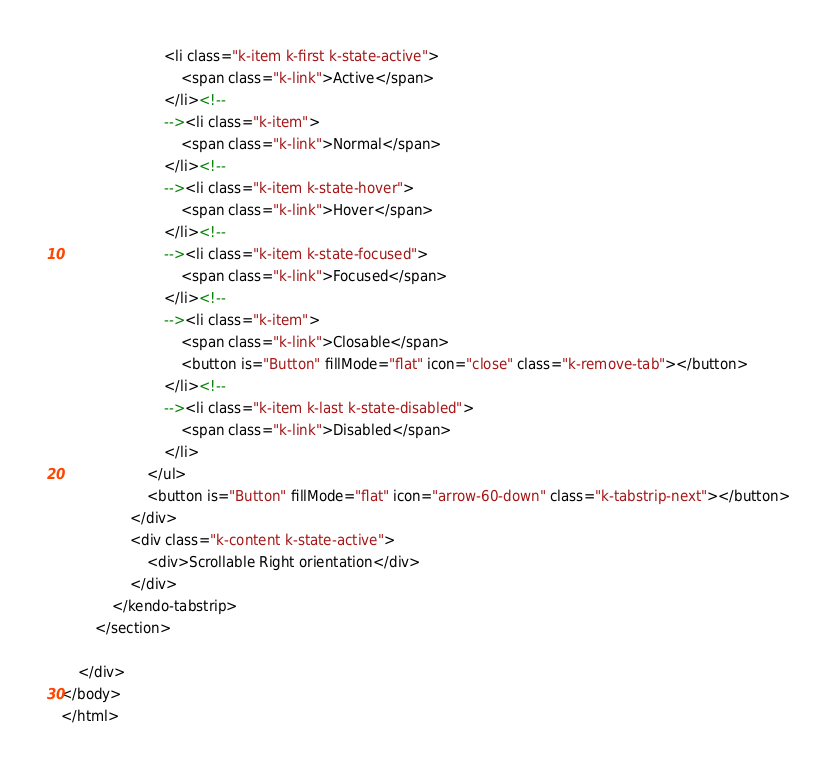<code> <loc_0><loc_0><loc_500><loc_500><_HTML_>                        <li class="k-item k-first k-state-active">
                            <span class="k-link">Active</span>
                        </li><!--
                        --><li class="k-item">
                            <span class="k-link">Normal</span>
                        </li><!--
                        --><li class="k-item k-state-hover">
                            <span class="k-link">Hover</span>
                        </li><!--
                        --><li class="k-item k-state-focused">
                            <span class="k-link">Focused</span>
                        </li><!--
                        --><li class="k-item">
                            <span class="k-link">Closable</span>
                            <button is="Button" fillMode="flat" icon="close" class="k-remove-tab"></button>
                        </li><!--
                        --><li class="k-item k-last k-state-disabled">
                            <span class="k-link">Disabled</span>
                        </li>
                    </ul>
                    <button is="Button" fillMode="flat" icon="arrow-60-down" class="k-tabstrip-next"></button>
                </div>
                <div class="k-content k-state-active">
                    <div>Scrollable Right orientation</div>
                </div>
            </kendo-tabstrip>
        </section>

    </div>
</body>
</html>
</code> 